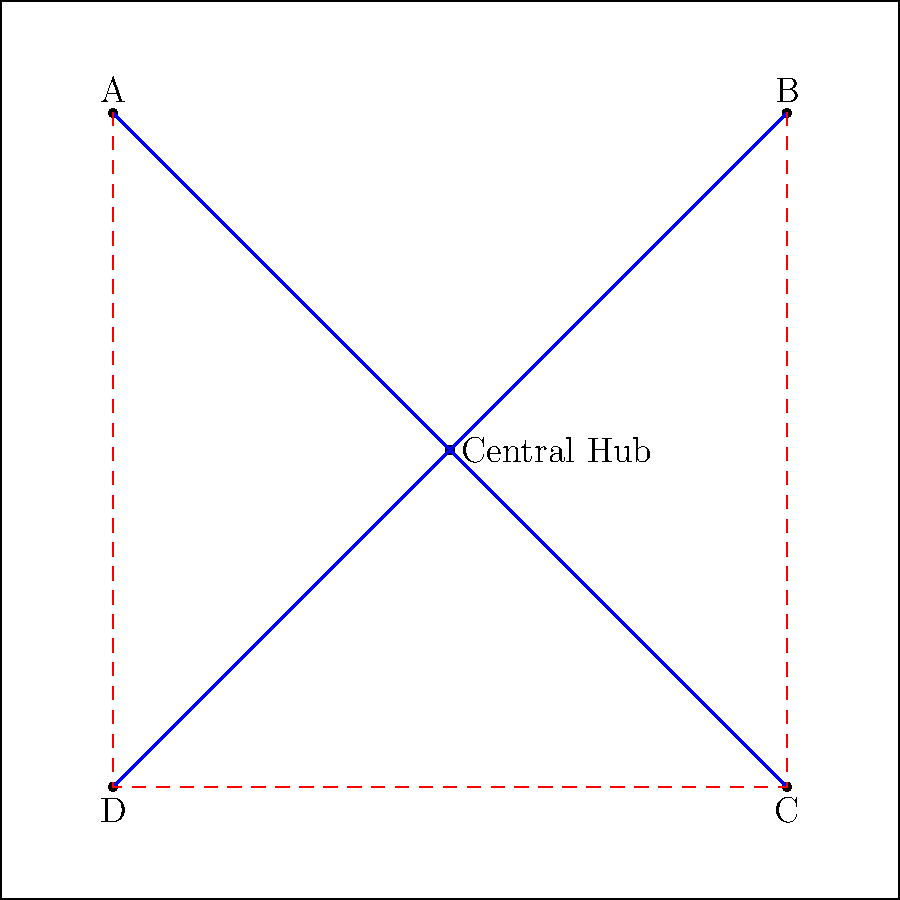Given the simplified city map with key landmarks A, B, C, and D, and a central hub, an existing bus network connects the landmarks to the central hub (blue lines). To improve efficiency, a new circular route (red dashed line) is proposed. What is the main advantage of implementing this new route in terms of passenger travel and network efficiency? To answer this question, let's analyze the existing network and the proposed new route:

1. Existing network (blue lines):
   - Connects landmarks A, B, C, and D to the central hub
   - Passengers must travel through the central hub to reach other landmarks
   - This creates a "hub-and-spoke" system

2. Proposed new route (red dashed line):
   - Creates a circular route connecting all four landmarks directly
   - Bypasses the central hub for travel between landmarks

3. Advantages of the new route:
   a) Direct connections: Passengers can travel between landmarks without going through the central hub
   b) Reduced travel time: Direct routes are generally faster than hub-and-spoke systems for inter-landmark travel
   c) Reduced congestion at the central hub: Fewer passengers need to transfer at the hub
   d) Increased network resilience: If the central hub is unavailable, passengers can still travel between landmarks
   e) Improved coverage: The new route covers areas between landmarks that were previously unserved

4. Main advantage:
   The primary benefit is the creation of direct connections between landmarks, eliminating the need for transfers at the central hub for inter-landmark travel. This reduces travel time and improves overall network efficiency.
Answer: Direct connections between landmarks, reducing travel time and transfers 